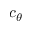<formula> <loc_0><loc_0><loc_500><loc_500>c _ { \theta }</formula> 